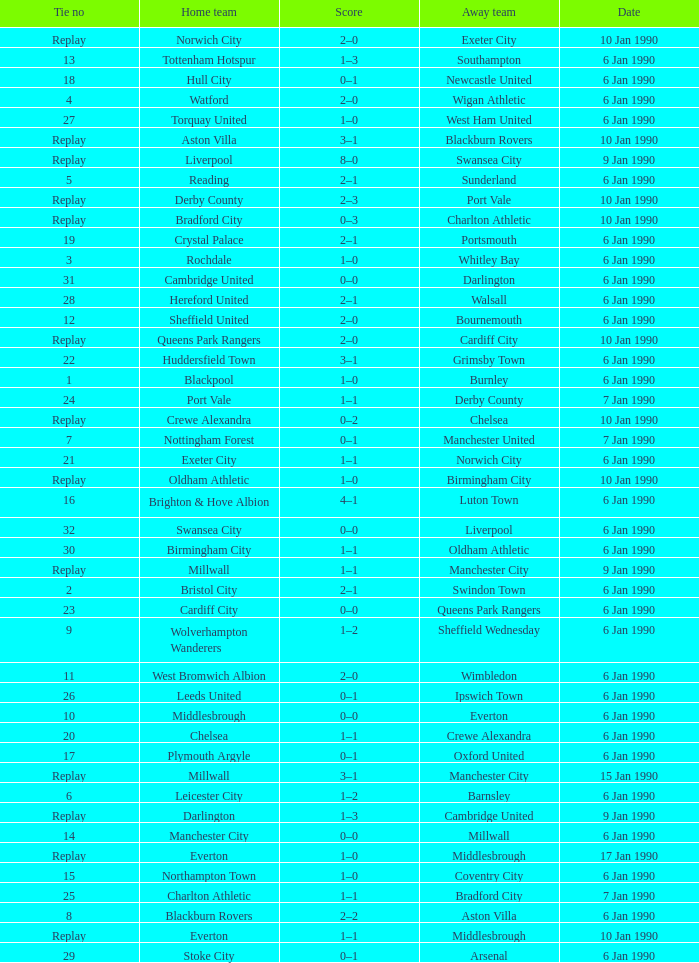What date did home team liverpool play? 9 Jan 1990. 